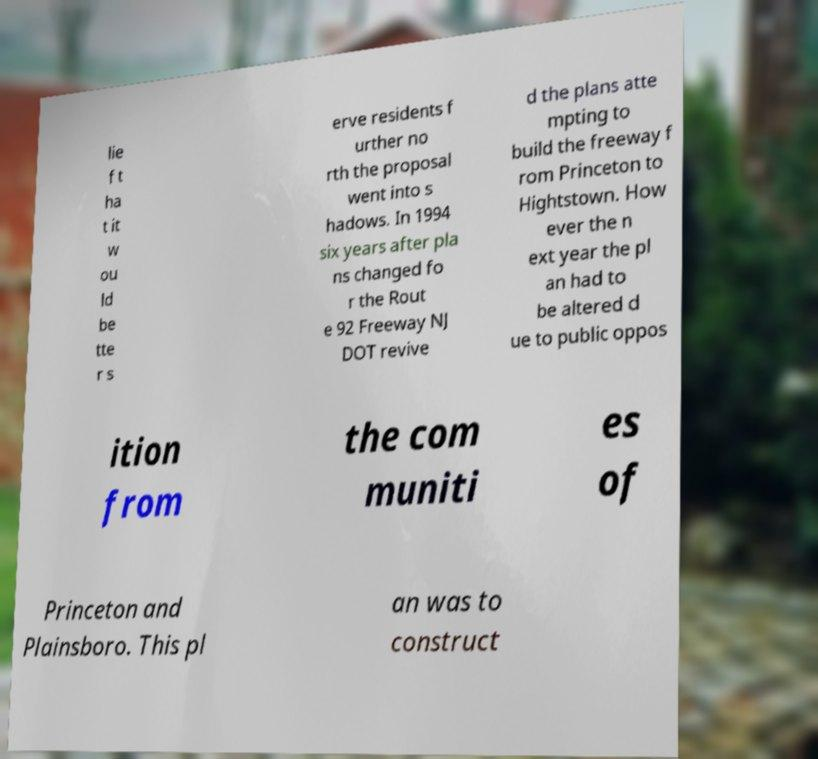What messages or text are displayed in this image? I need them in a readable, typed format. lie f t ha t it w ou ld be tte r s erve residents f urther no rth the proposal went into s hadows. In 1994 six years after pla ns changed fo r the Rout e 92 Freeway NJ DOT revive d the plans atte mpting to build the freeway f rom Princeton to Hightstown. How ever the n ext year the pl an had to be altered d ue to public oppos ition from the com muniti es of Princeton and Plainsboro. This pl an was to construct 